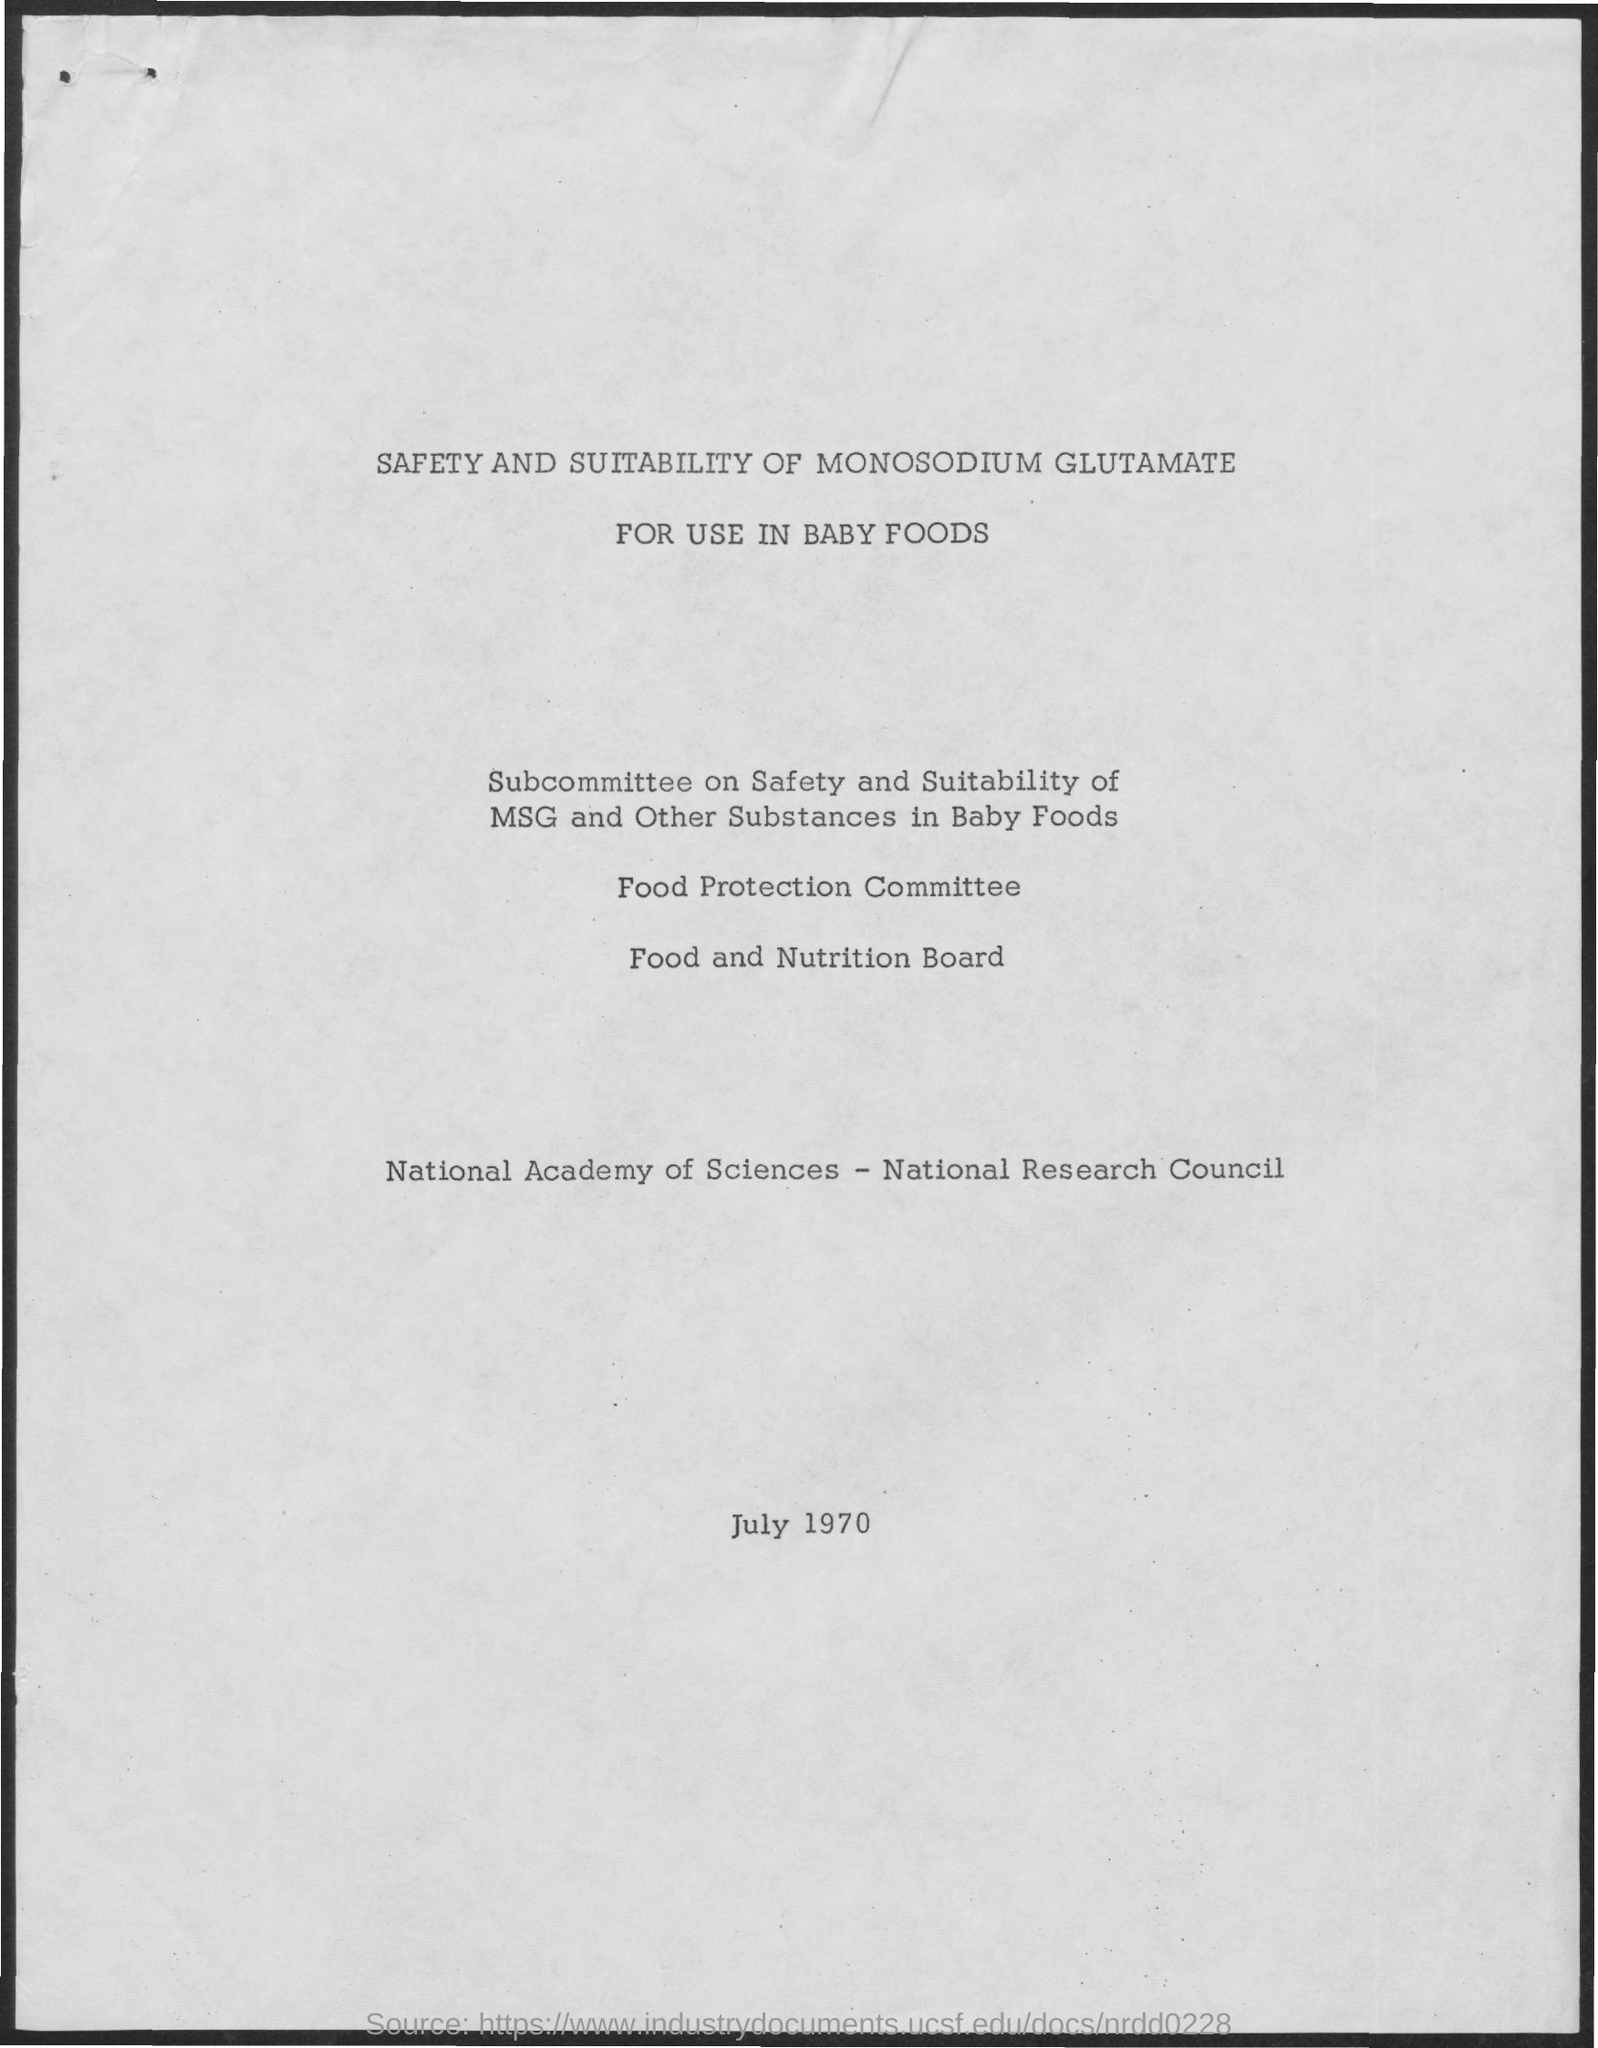What is the date mentioned in the document?
Keep it short and to the point. July 1970. 